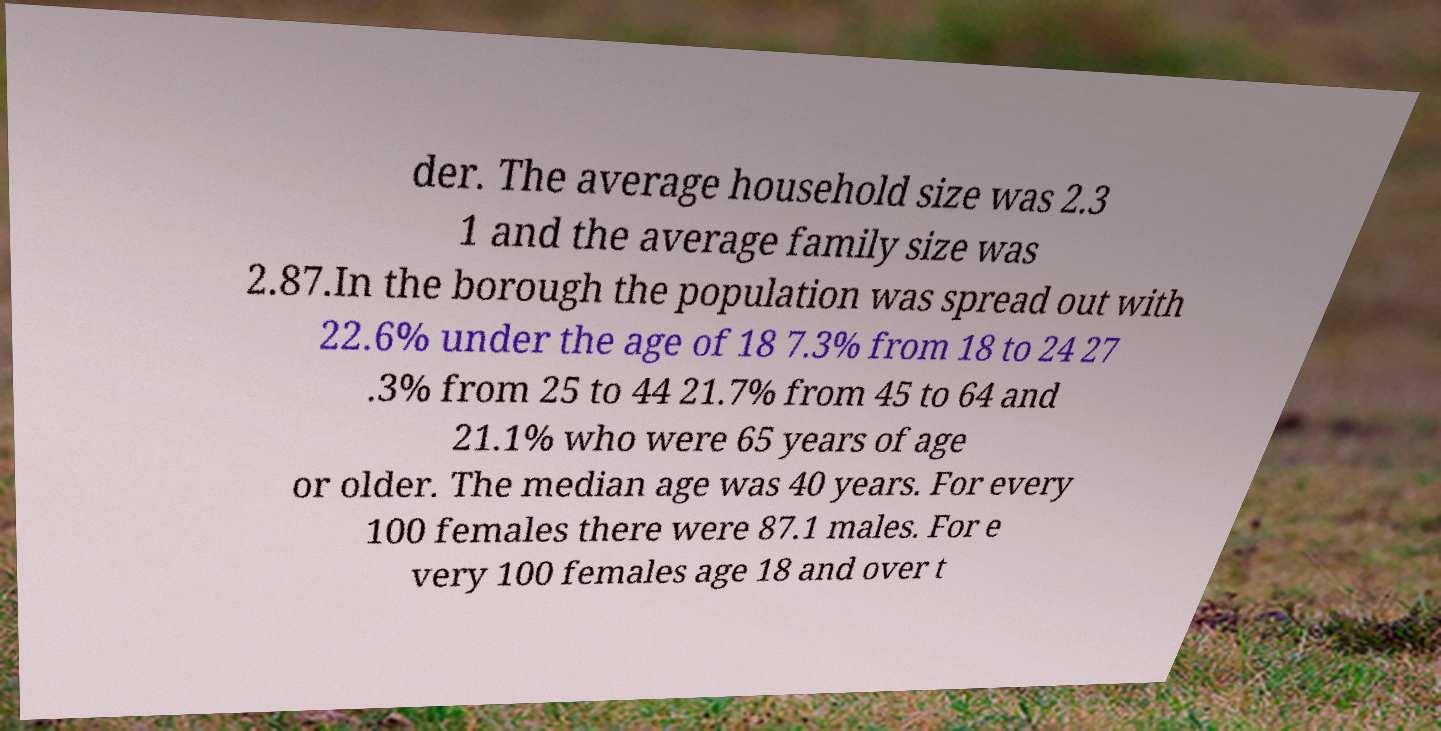I need the written content from this picture converted into text. Can you do that? der. The average household size was 2.3 1 and the average family size was 2.87.In the borough the population was spread out with 22.6% under the age of 18 7.3% from 18 to 24 27 .3% from 25 to 44 21.7% from 45 to 64 and 21.1% who were 65 years of age or older. The median age was 40 years. For every 100 females there were 87.1 males. For e very 100 females age 18 and over t 